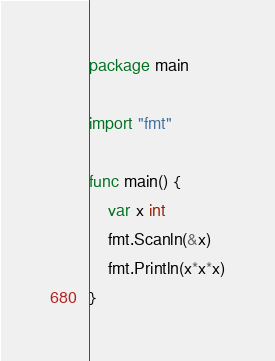Convert code to text. <code><loc_0><loc_0><loc_500><loc_500><_Go_>package main

import "fmt"

func main() {
    var x int
    fmt.Scanln(&x)
    fmt.Println(x*x*x)
}
</code> 